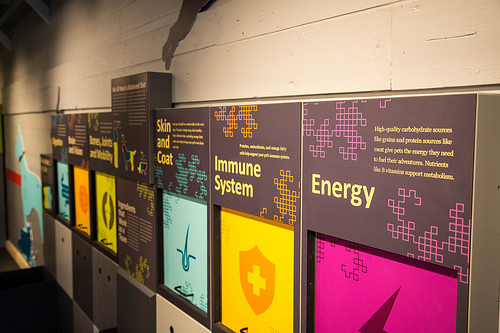<image>
Is the orange to the right of the yellow? No. The orange is not to the right of the yellow. The horizontal positioning shows a different relationship. 